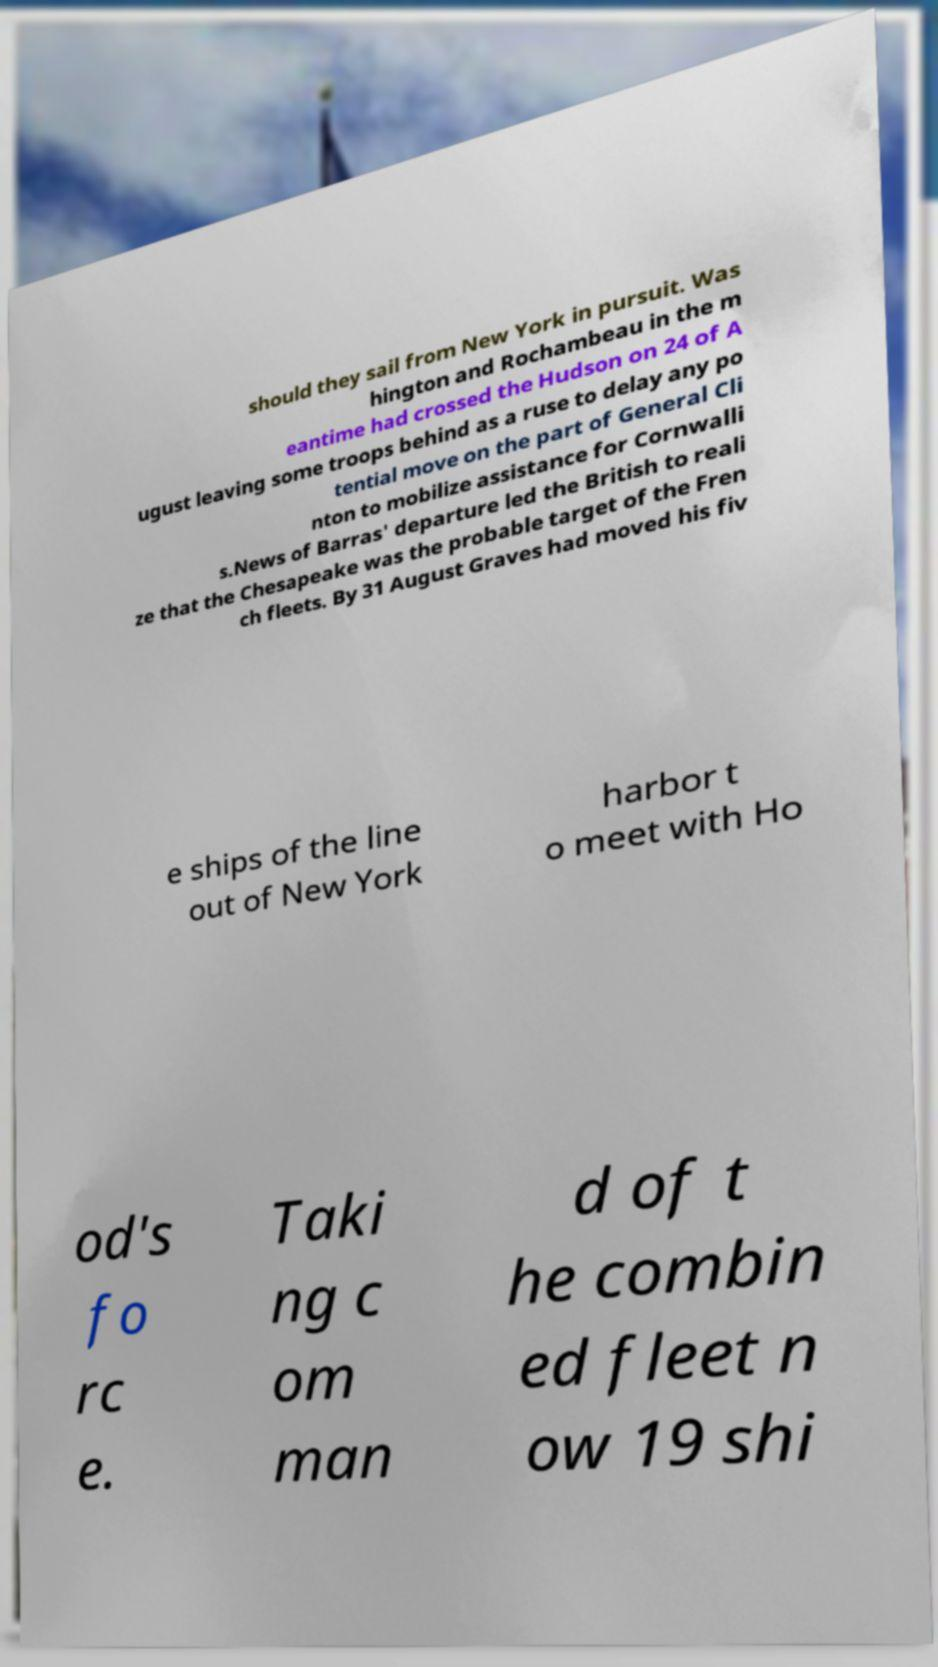Can you read and provide the text displayed in the image?This photo seems to have some interesting text. Can you extract and type it out for me? should they sail from New York in pursuit. Was hington and Rochambeau in the m eantime had crossed the Hudson on 24 of A ugust leaving some troops behind as a ruse to delay any po tential move on the part of General Cli nton to mobilize assistance for Cornwalli s.News of Barras' departure led the British to reali ze that the Chesapeake was the probable target of the Fren ch fleets. By 31 August Graves had moved his fiv e ships of the line out of New York harbor t o meet with Ho od's fo rc e. Taki ng c om man d of t he combin ed fleet n ow 19 shi 